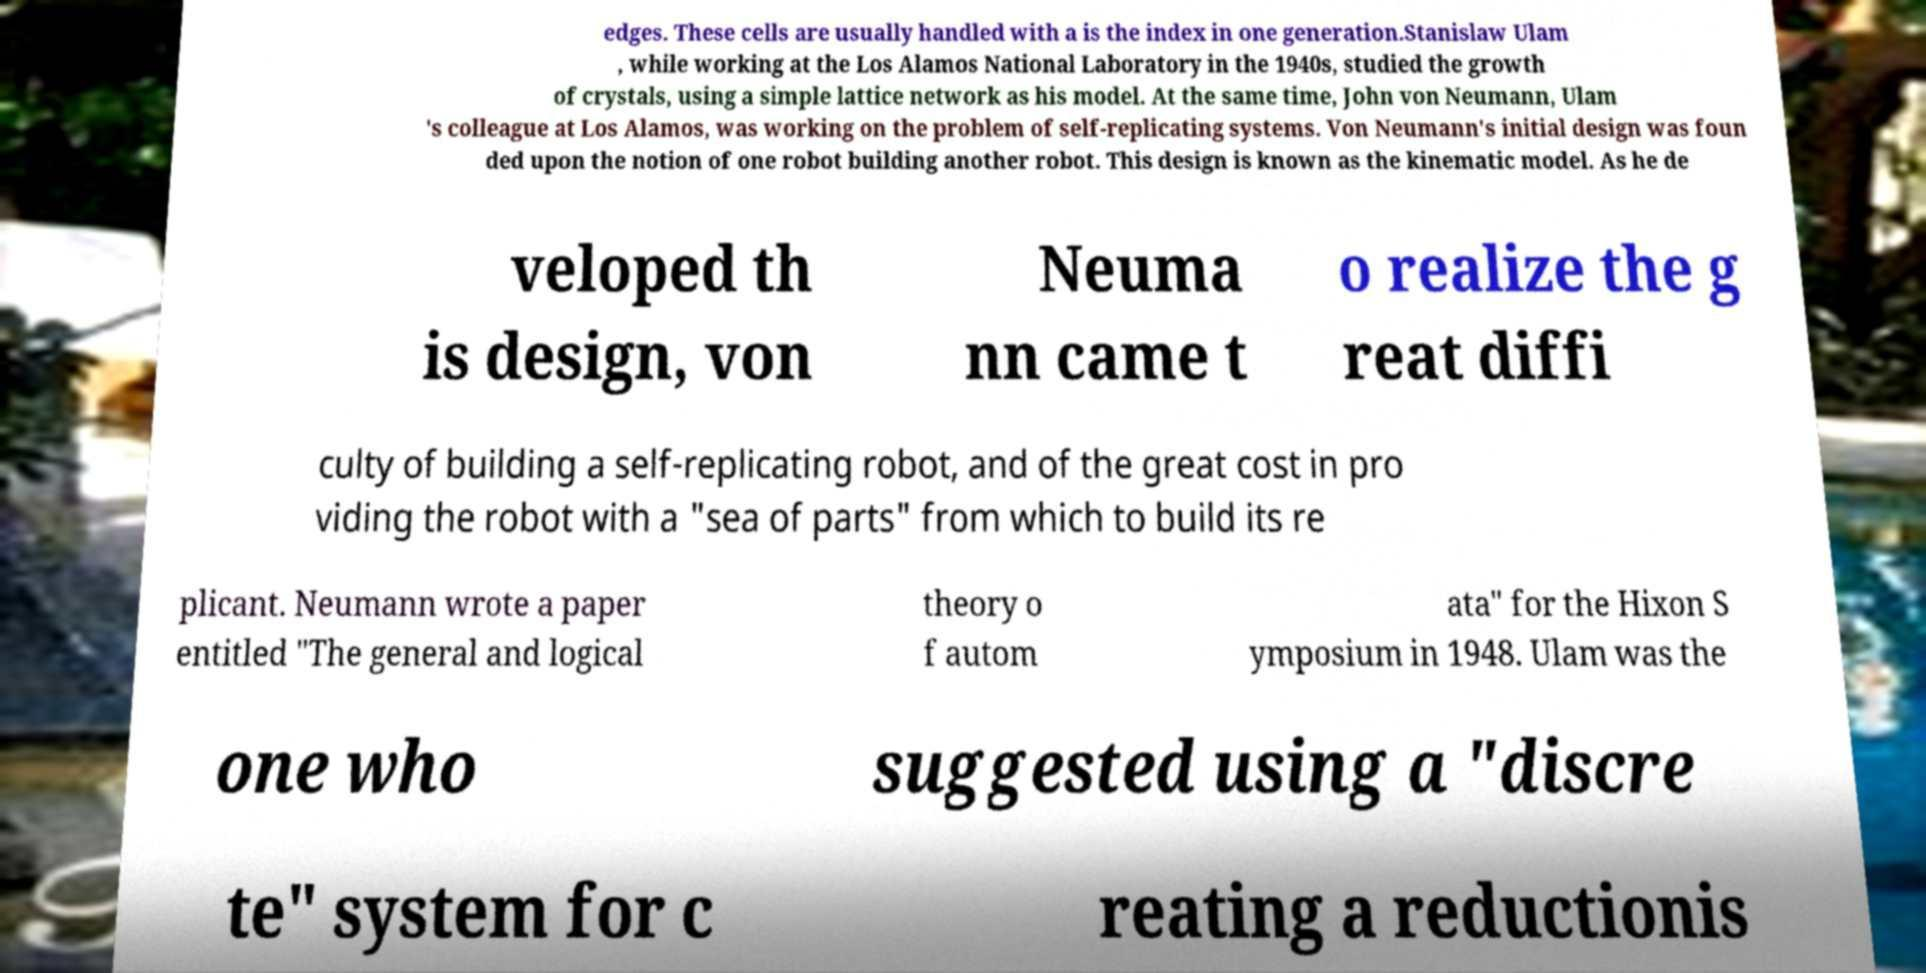I need the written content from this picture converted into text. Can you do that? edges. These cells are usually handled with a is the index in one generation.Stanislaw Ulam , while working at the Los Alamos National Laboratory in the 1940s, studied the growth of crystals, using a simple lattice network as his model. At the same time, John von Neumann, Ulam 's colleague at Los Alamos, was working on the problem of self-replicating systems. Von Neumann's initial design was foun ded upon the notion of one robot building another robot. This design is known as the kinematic model. As he de veloped th is design, von Neuma nn came t o realize the g reat diffi culty of building a self-replicating robot, and of the great cost in pro viding the robot with a "sea of parts" from which to build its re plicant. Neumann wrote a paper entitled "The general and logical theory o f autom ata" for the Hixon S ymposium in 1948. Ulam was the one who suggested using a "discre te" system for c reating a reductionis 